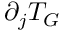Convert formula to latex. <formula><loc_0><loc_0><loc_500><loc_500>\partial _ { j } T _ { G }</formula> 